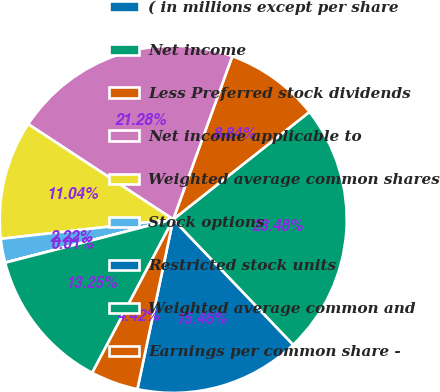Convert chart to OTSL. <chart><loc_0><loc_0><loc_500><loc_500><pie_chart><fcel>( in millions except per share<fcel>Net income<fcel>Less Preferred stock dividends<fcel>Net income applicable to<fcel>Weighted average common shares<fcel>Stock options<fcel>Restricted stock units<fcel>Weighted average common and<fcel>Earnings per common share -<nl><fcel>15.46%<fcel>23.48%<fcel>8.84%<fcel>21.28%<fcel>11.04%<fcel>2.22%<fcel>0.01%<fcel>13.25%<fcel>4.42%<nl></chart> 